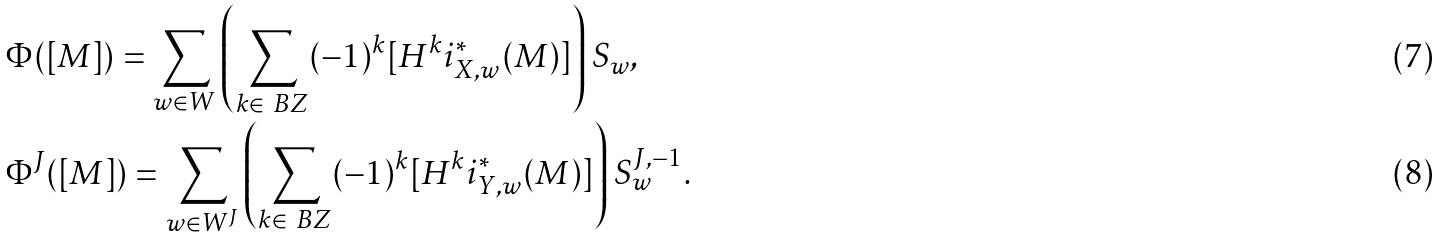<formula> <loc_0><loc_0><loc_500><loc_500>& \Phi ( [ M ] ) = \sum _ { w \in W } \left ( \sum _ { k \in \ B Z } ( - 1 ) ^ { k } [ H ^ { k } i _ { X , w } ^ { * } ( M ) ] \right ) S _ { w } , \\ & \Phi ^ { J } ( [ M ] ) = \sum _ { w \in W ^ { J } } \left ( \sum _ { k \in \ B Z } ( - 1 ) ^ { k } [ H ^ { k } i _ { Y , w } ^ { * } ( M ) ] \right ) S ^ { J , - 1 } _ { w } .</formula> 